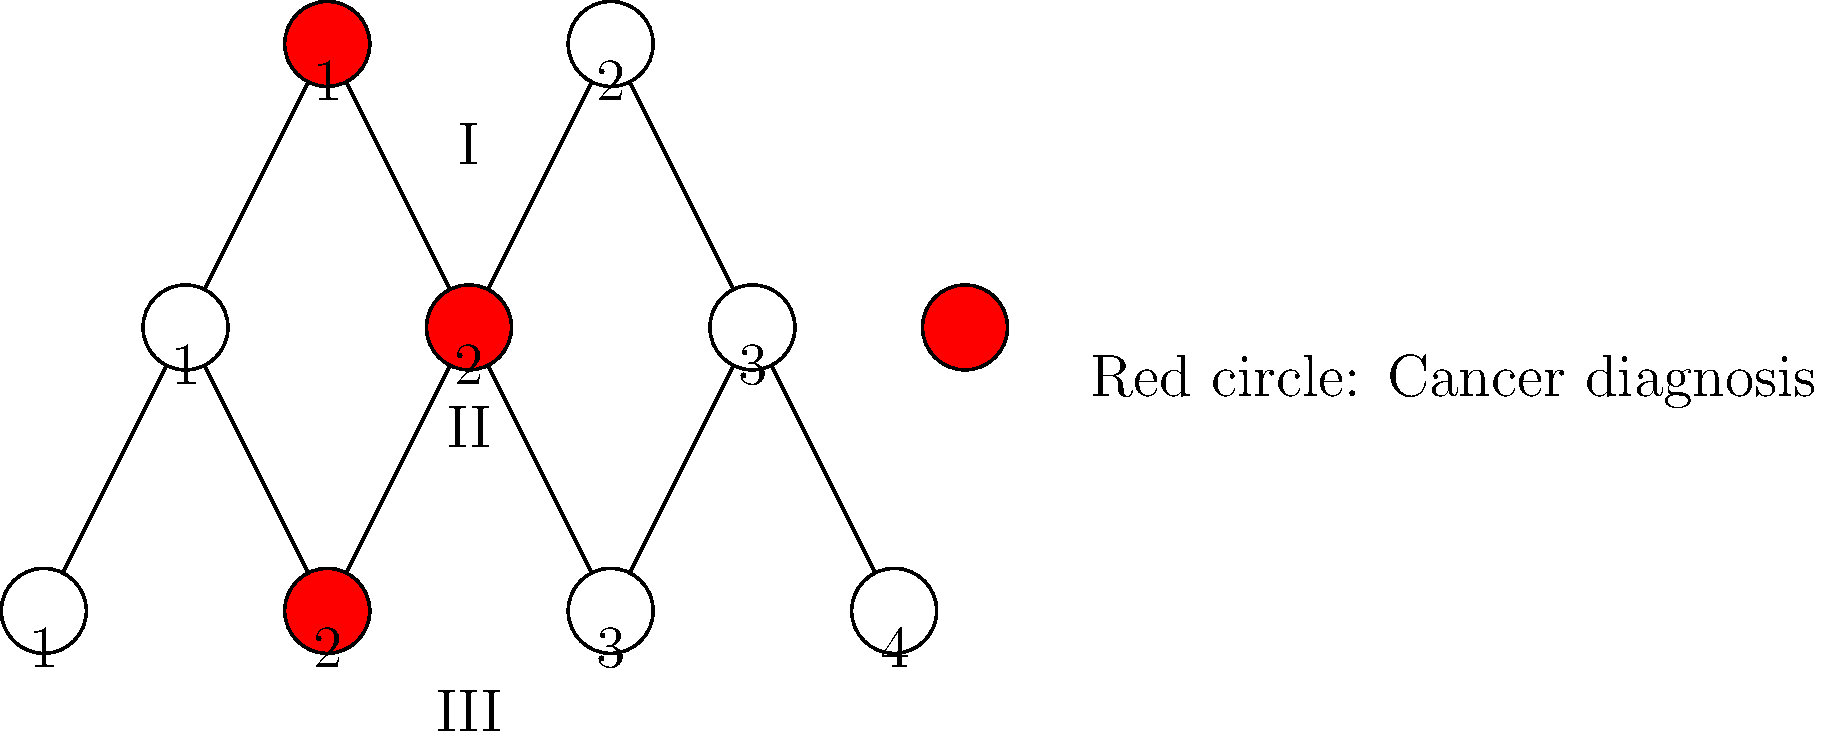Based on the family tree diagram showing cancer incidence across generations, what is the probability that an individual in generation III will develop cancer, assuming they inherit the genetic predisposition? To determine the probability of an individual in generation III developing cancer, given they inherit the genetic predisposition, we need to follow these steps:

1. Identify the affected individuals:
   Generation I: 1 out of 2 (50%)
   Generation II: 1 out of 3 (33.3%)
   Generation III: 1 out of 4 (25%)

2. Observe the pattern of inheritance:
   The cancer incidence appears to follow an autosomal dominant inheritance pattern, as it affects both males and females and is present in each generation.

3. Calculate the probability of inheriting the genetic predisposition:
   In autosomal dominant inheritance, there's a 50% chance of passing the gene to offspring.

4. Analyze the penetrance:
   Penetrance is the likelihood of developing the disease if you have the gene. In this case, not everyone with the gene develops cancer, indicating incomplete penetrance.

5. Estimate the penetrance:
   Generation I: 1/1 = 100%
   Generation II: 1/2 = 50% (assuming both I-1 and I-2 passed the gene)
   Generation III: 1/3 = 33.3% (assuming II-2 and II-3 both carry the gene)

6. Calculate the average penetrance:
   (100% + 50% + 33.3%) / 3 ≈ 61.1%

Therefore, if an individual in generation III inherits the genetic predisposition, their probability of developing cancer is approximately 61.1%.
Answer: 61.1% 